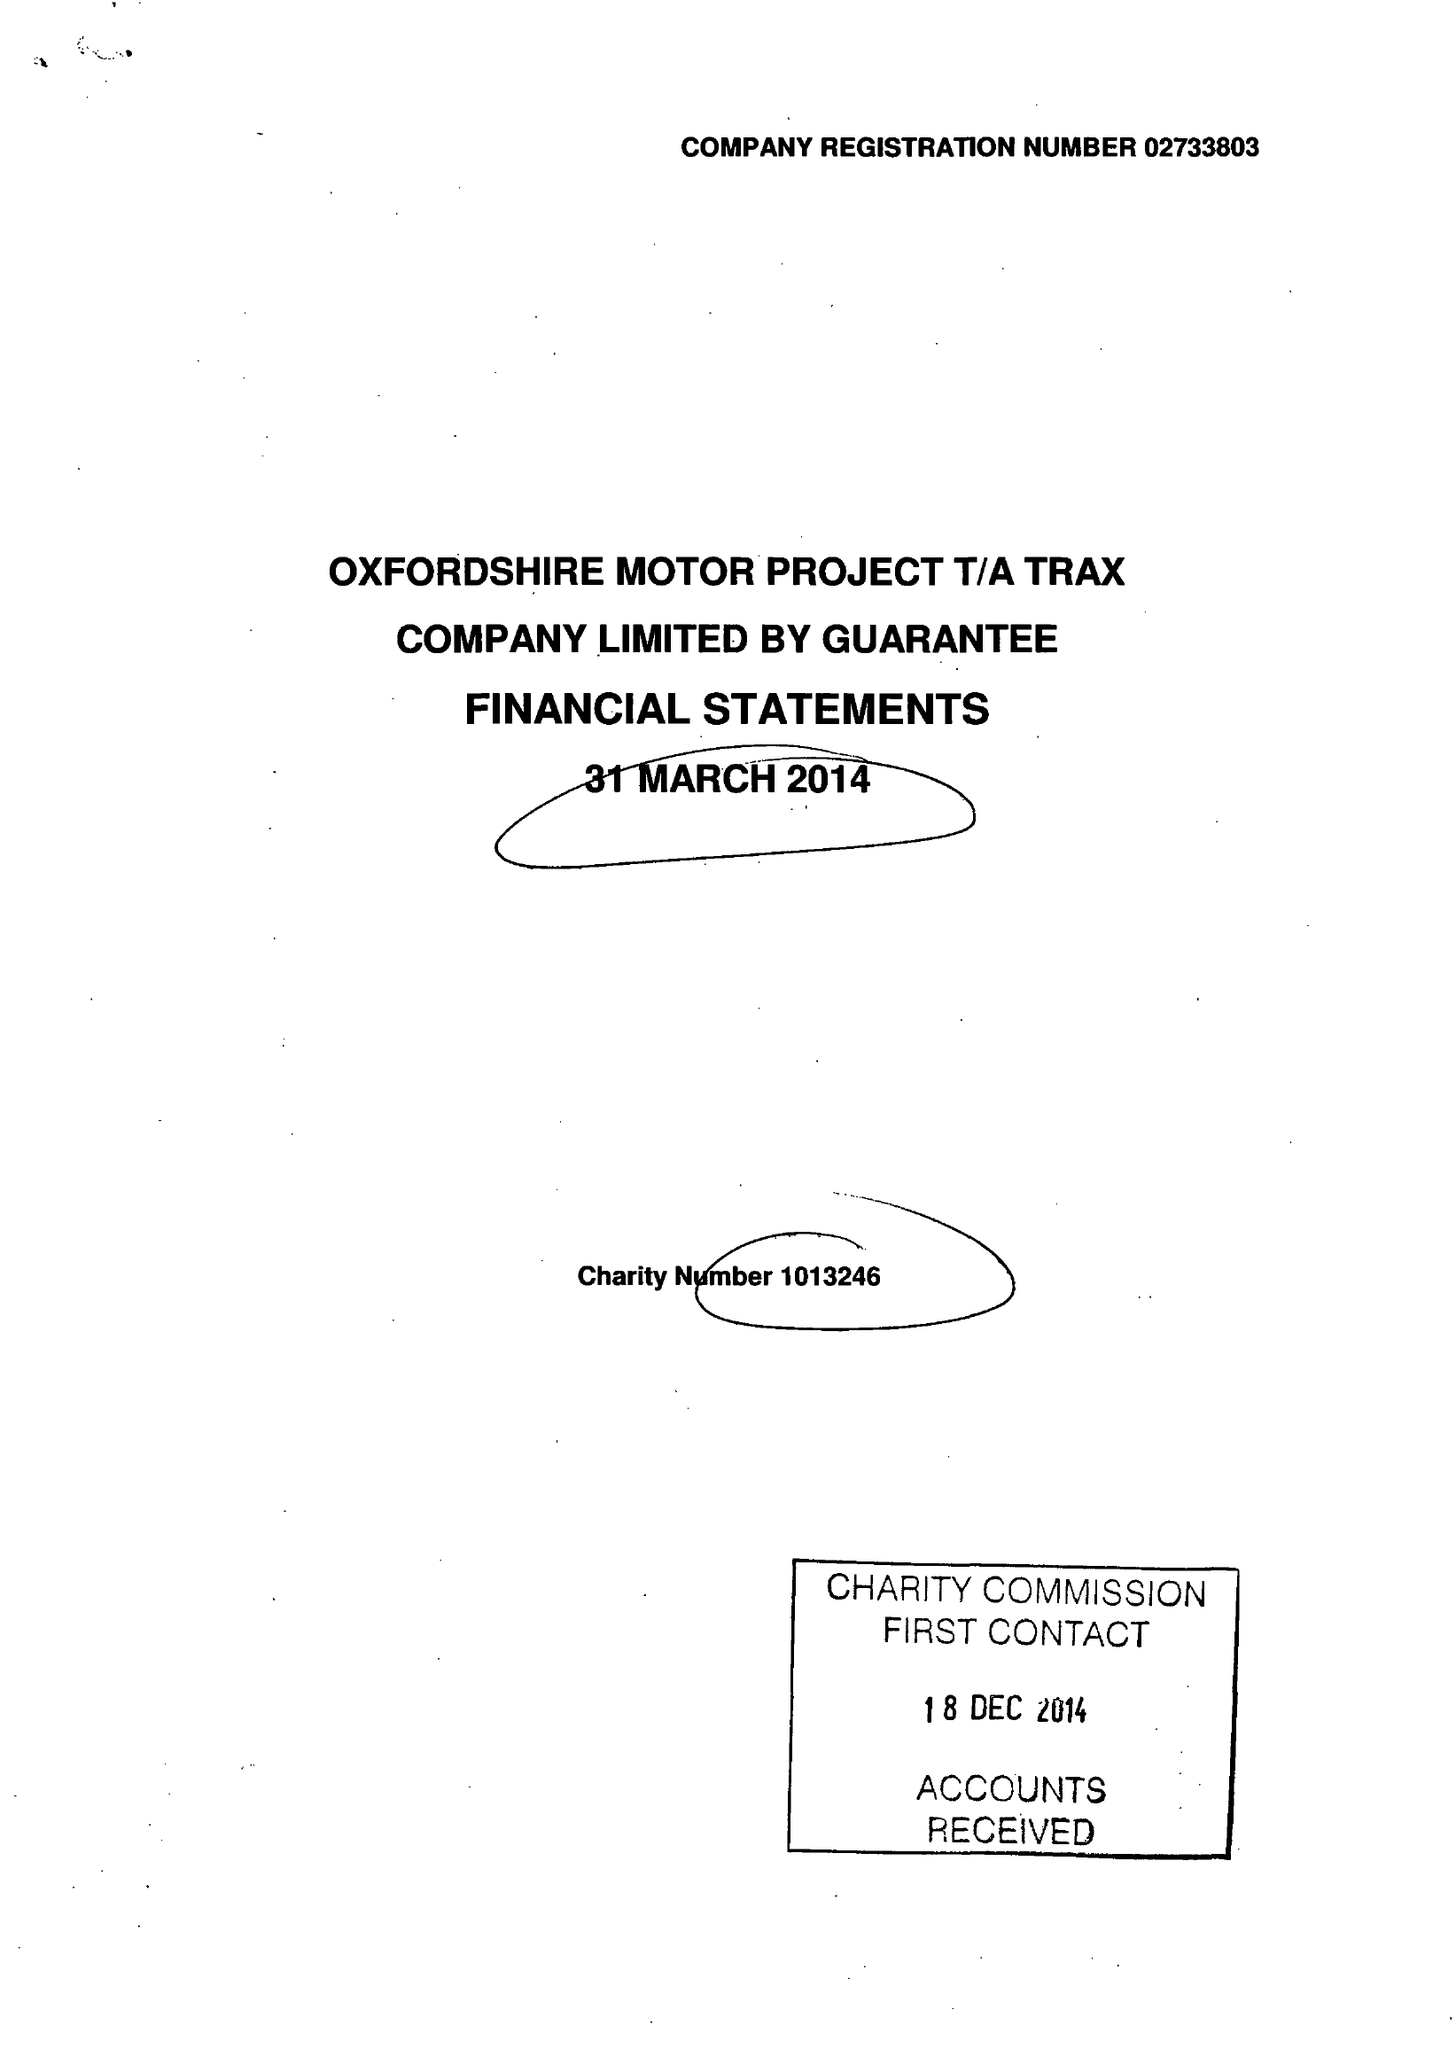What is the value for the spending_annually_in_british_pounds?
Answer the question using a single word or phrase. 324990.00 